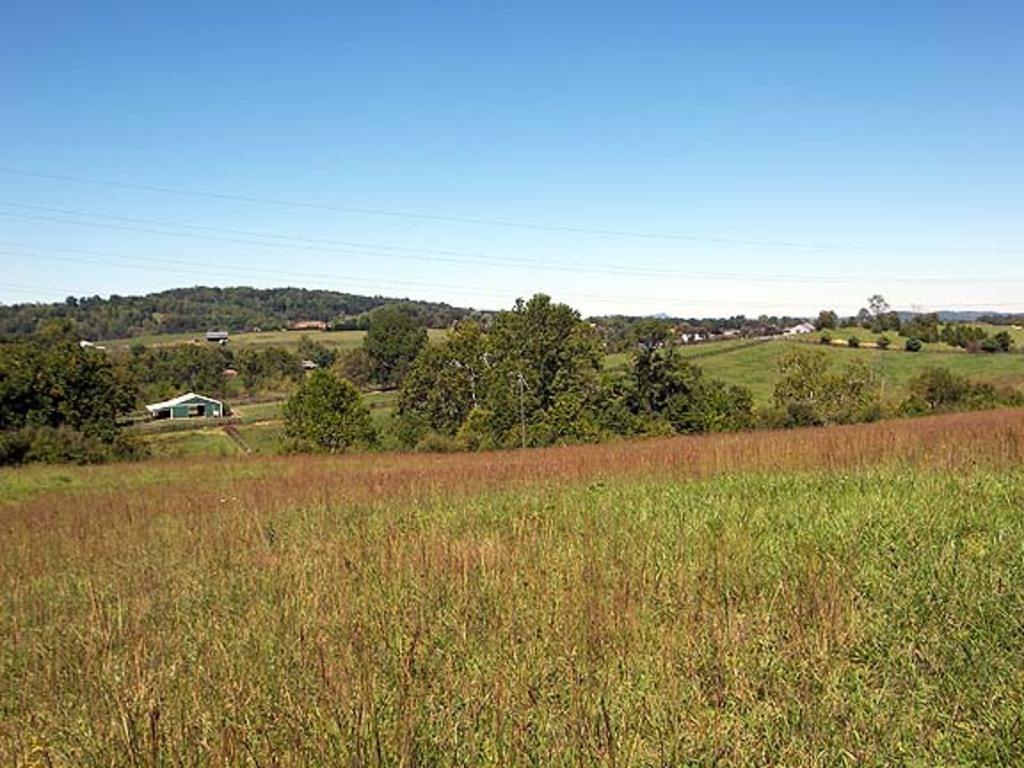What type of terrain is at the bottom of the image? There is grassland at the bottom side of the image. What can be seen in the background of the image? There are trees, houses, wires, and the sky visible in the background of the image. What type of authority figure can be seen in the image? There is no authority figure present in the image. How does the earthquake affect the grassland in the image? There is no earthquake present in the image, so its effects cannot be observed. 